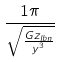<formula> <loc_0><loc_0><loc_500><loc_500>\frac { 1 \pi } { \sqrt { \frac { G z _ { l b n } } { y ^ { 3 } } } }</formula> 